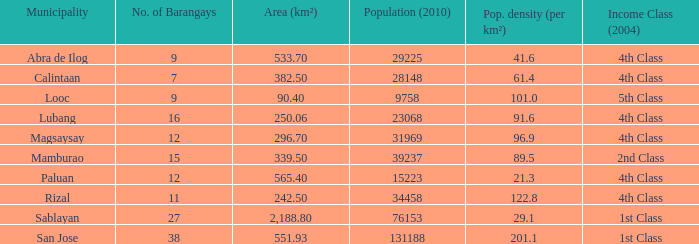What was the tiniest population in 2010? 9758.0. 